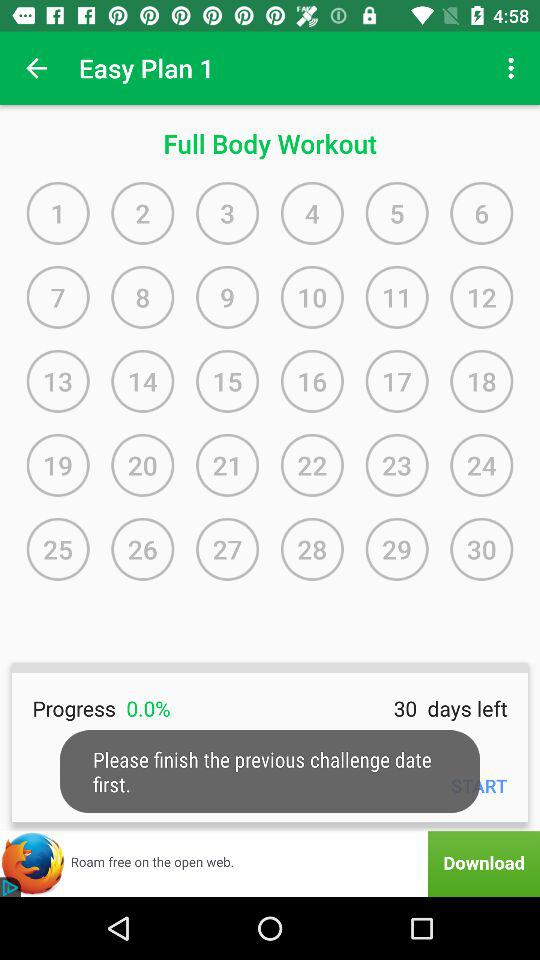How many days are left? There are 30 days left. 